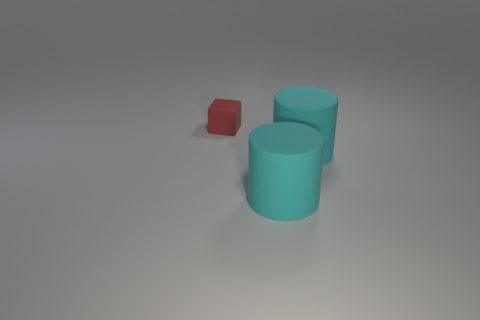Add 3 big cyan rubber things. How many objects exist? 6 Subtract all cylinders. How many objects are left? 1 Subtract all tiny brown shiny blocks. Subtract all rubber objects. How many objects are left? 0 Add 1 cyan cylinders. How many cyan cylinders are left? 3 Add 1 matte things. How many matte things exist? 4 Subtract 0 yellow cylinders. How many objects are left? 3 